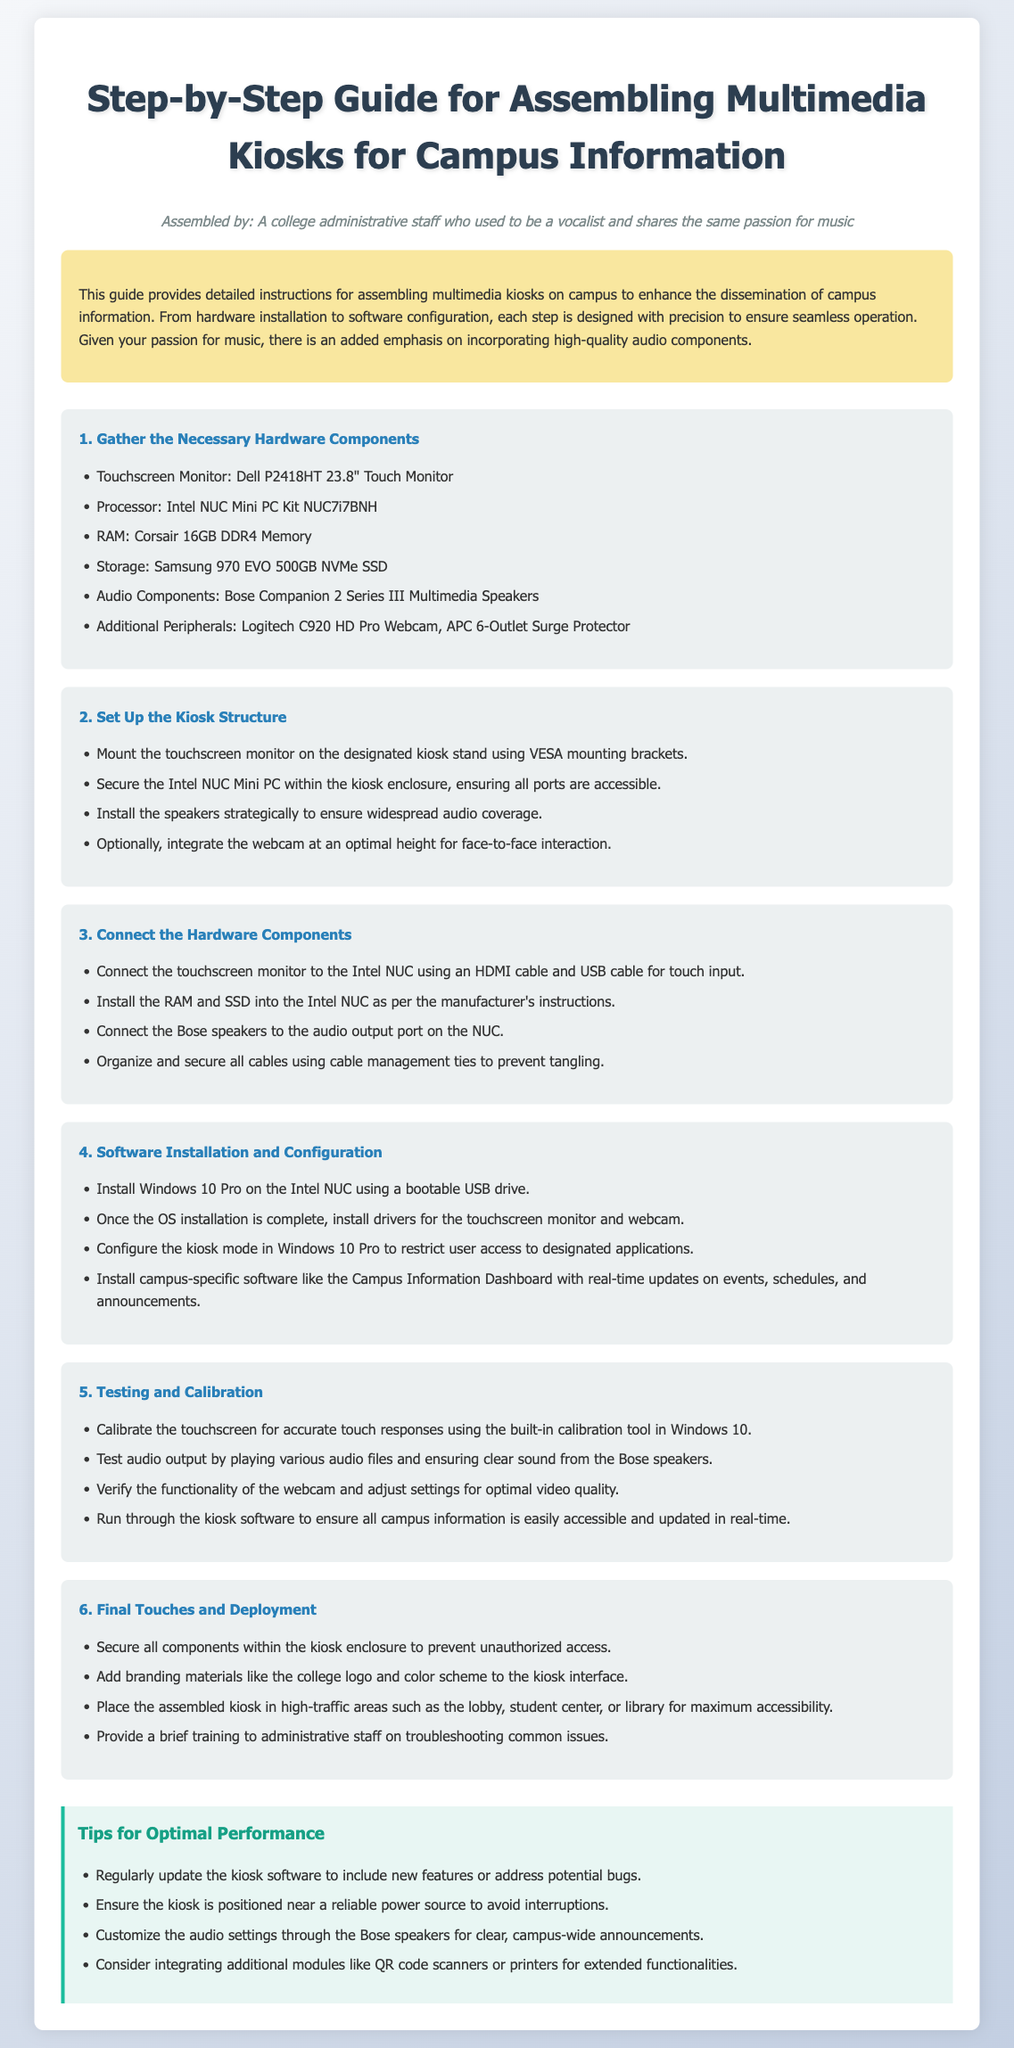What is the main purpose of this guide? The guide provides detailed instructions for assembling multimedia kiosks on campus to enhance the dissemination of campus information.
Answer: Enhance campus information dissemination How many hardware components are listed in the guide? The guide specifies a list of components to gather, which includes six hardware items.
Answer: Six What is the model of the touchscreen monitor? The specified touchscreen monitor in the guide is a Dell P2418HT 23.8" Touch Monitor.
Answer: Dell P2418HT 23.8" Touch Monitor What should be used to secure the touchscreen monitor? The guide mentions using VESA mounting brackets to mount the touchscreen monitor.
Answer: VESA mounting brackets What operating system is installed on the Intel NUC? The guide states that Windows 10 Pro is to be installed on the Intel NUC.
Answer: Windows 10 Pro Why is there an emphasis on audio components in the guide? Given the author's passion for music, the guide emphasizes incorporating high-quality audio components for better sound quality.
Answer: High-quality audio components How should the kiosk be positioned for maximum accessibility? The guide suggests placing the assembled kiosk in high-traffic areas such as the lobby, student center, or library.
Answer: High-traffic areas What is the suggested method for cable management? The guide advises using cable management ties to organize and secure all cables.
Answer: Cable management ties Which component is optional to integrate for face-to-face interaction? The guide mentions the webcam as an optional component to integrate at an optimal height.
Answer: Webcam 